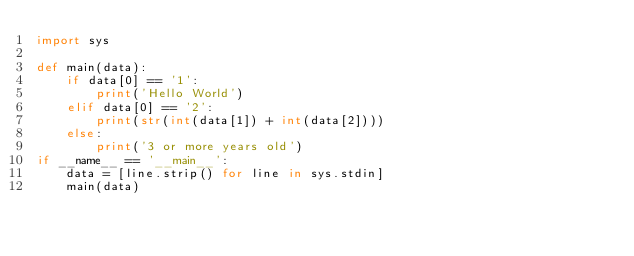Convert code to text. <code><loc_0><loc_0><loc_500><loc_500><_Python_>import sys

def main(data):
    if data[0] == '1':
        print('Hello World')
    elif data[0] == '2':
        print(str(int(data[1]) + int(data[2])))
    else:
        print('3 or more years old')
if __name__ == '__main__':
    data = [line.strip() for line in sys.stdin]
    main(data)</code> 